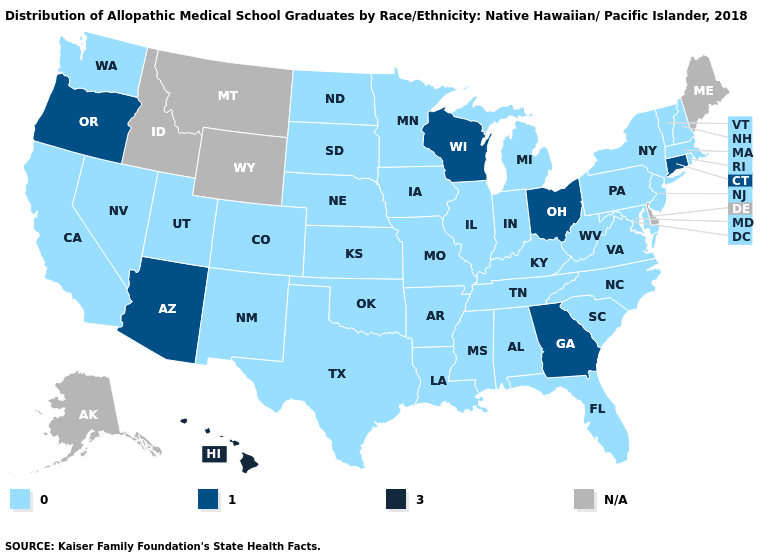Which states have the lowest value in the South?
Write a very short answer. Alabama, Arkansas, Florida, Kentucky, Louisiana, Maryland, Mississippi, North Carolina, Oklahoma, South Carolina, Tennessee, Texas, Virginia, West Virginia. Does South Carolina have the highest value in the South?
Concise answer only. No. Among the states that border North Carolina , which have the lowest value?
Concise answer only. South Carolina, Tennessee, Virginia. Which states have the highest value in the USA?
Quick response, please. Hawaii. Name the states that have a value in the range N/A?
Quick response, please. Alaska, Delaware, Idaho, Maine, Montana, Wyoming. Name the states that have a value in the range 0.0?
Keep it brief. Alabama, Arkansas, California, Colorado, Florida, Illinois, Indiana, Iowa, Kansas, Kentucky, Louisiana, Maryland, Massachusetts, Michigan, Minnesota, Mississippi, Missouri, Nebraska, Nevada, New Hampshire, New Jersey, New Mexico, New York, North Carolina, North Dakota, Oklahoma, Pennsylvania, Rhode Island, South Carolina, South Dakota, Tennessee, Texas, Utah, Vermont, Virginia, Washington, West Virginia. Name the states that have a value in the range 1.0?
Give a very brief answer. Arizona, Connecticut, Georgia, Ohio, Oregon, Wisconsin. Name the states that have a value in the range 1.0?
Be succinct. Arizona, Connecticut, Georgia, Ohio, Oregon, Wisconsin. Which states have the lowest value in the USA?
Answer briefly. Alabama, Arkansas, California, Colorado, Florida, Illinois, Indiana, Iowa, Kansas, Kentucky, Louisiana, Maryland, Massachusetts, Michigan, Minnesota, Mississippi, Missouri, Nebraska, Nevada, New Hampshire, New Jersey, New Mexico, New York, North Carolina, North Dakota, Oklahoma, Pennsylvania, Rhode Island, South Carolina, South Dakota, Tennessee, Texas, Utah, Vermont, Virginia, Washington, West Virginia. What is the value of Texas?
Give a very brief answer. 0.0. What is the value of Florida?
Quick response, please. 0.0. Name the states that have a value in the range 3.0?
Write a very short answer. Hawaii. How many symbols are there in the legend?
Quick response, please. 4. Among the states that border New Mexico , which have the highest value?
Give a very brief answer. Arizona. 